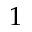Convert formula to latex. <formula><loc_0><loc_0><loc_500><loc_500>1</formula> 